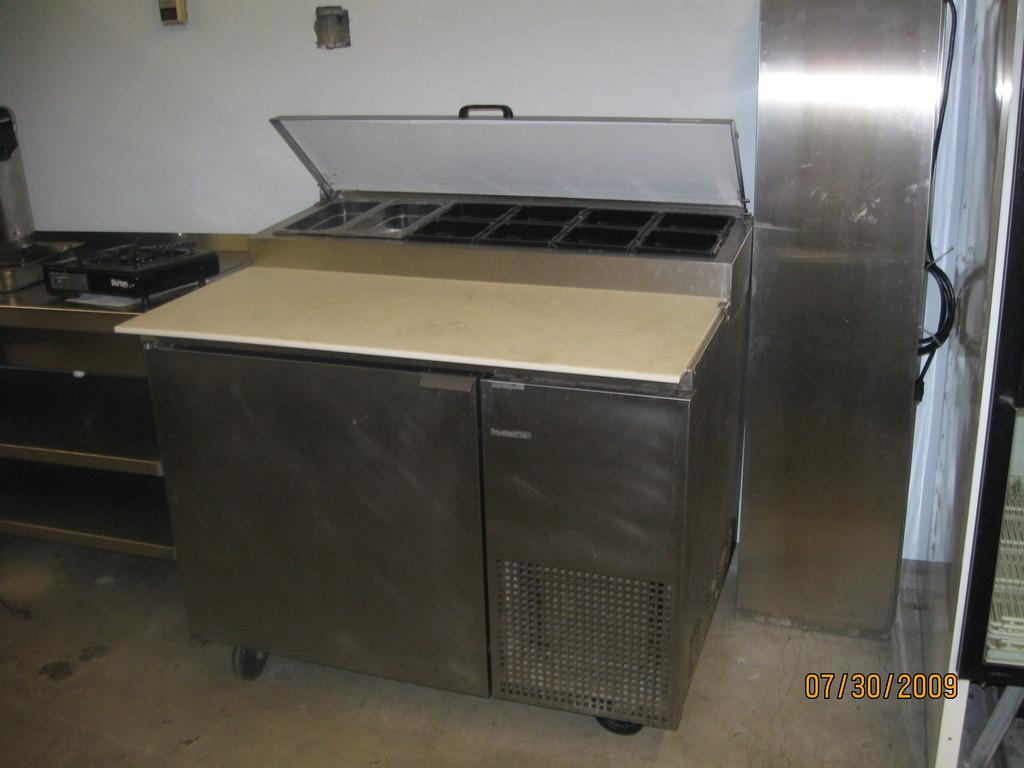<image>
Offer a succinct explanation of the picture presented. A picture of a stainless steel range which is dated 2009 